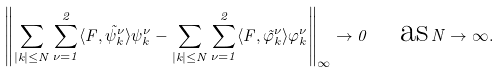<formula> <loc_0><loc_0><loc_500><loc_500>\left \| \sum _ { | k | \leq N } \sum _ { \nu = 1 } ^ { 2 } \langle F , \tilde { \psi } _ { k } ^ { \nu } \rangle \psi _ { k } ^ { \nu } - \sum _ { | k | \leq N } \sum _ { \nu = 1 } ^ { 2 } \langle F , \tilde { \varphi } _ { k } ^ { \nu } \rangle \varphi _ { k } ^ { \nu } \right \| _ { \infty } \to 0 \quad \text {as} \, N \to \infty .</formula> 